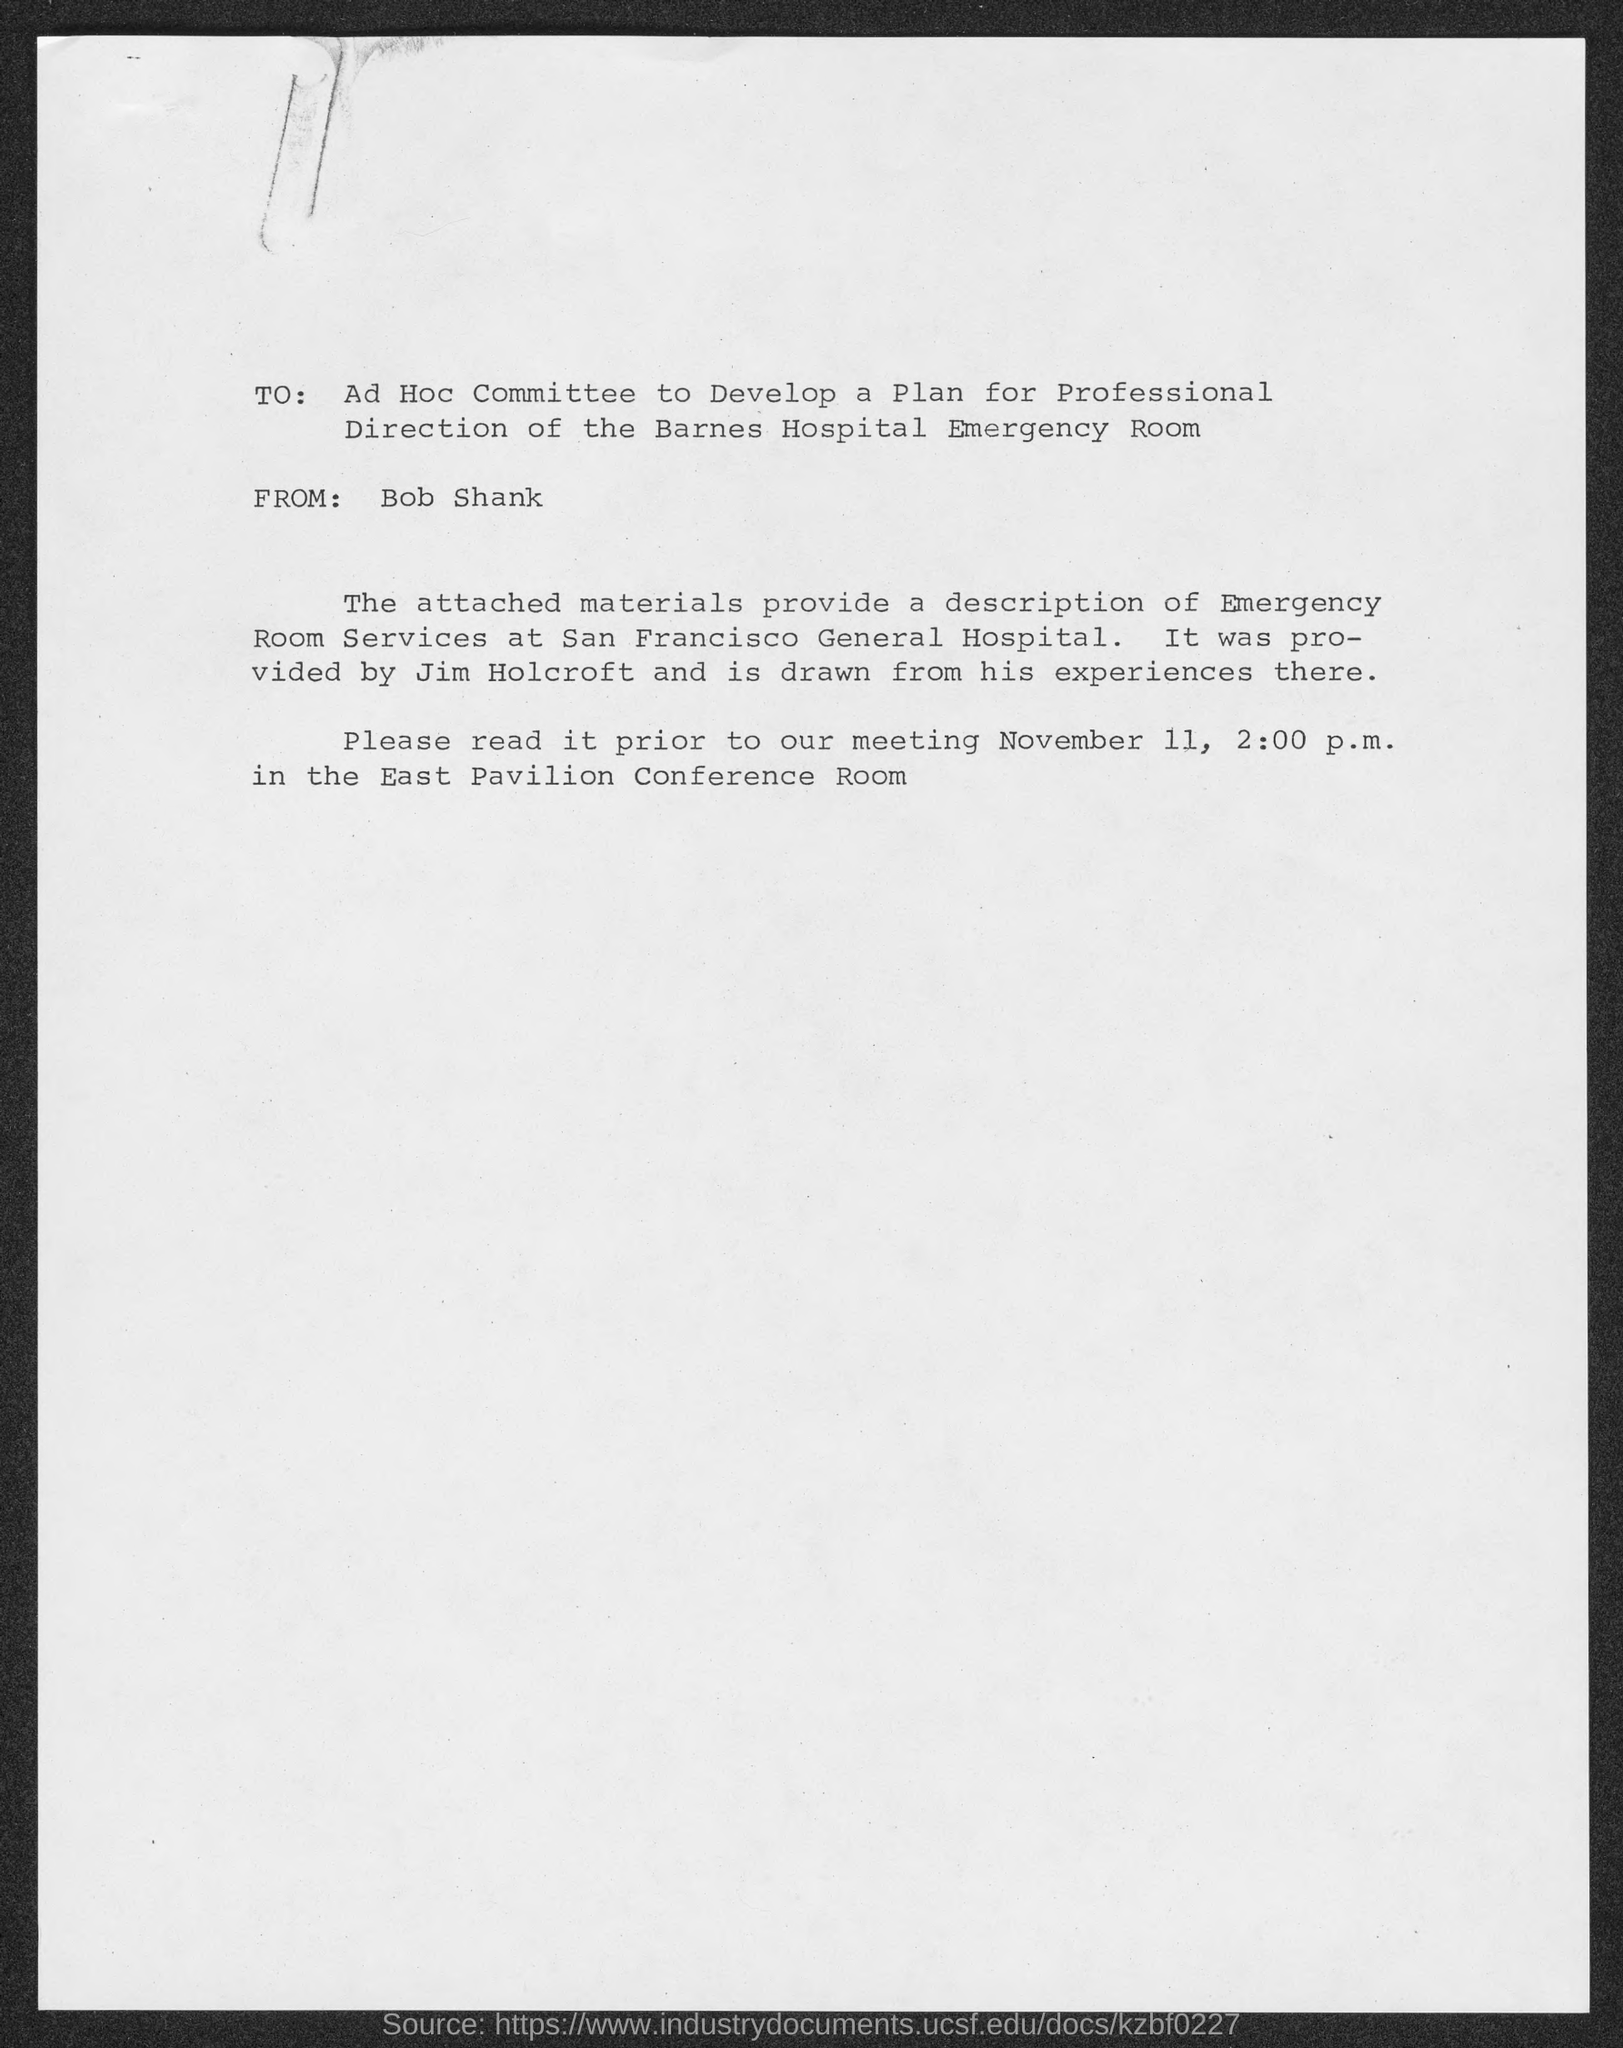Point out several critical features in this image. The meeting will be held in the East Pavilion Conference Room. The description of emergency room services at San Francisco General Hospital is provided by Jim Holcroft. The meeting is scheduled to take place at 2:00 P.M. The sender of this message is Bob Shank. The "Description of Emergency Room Services" at San Francisco General Hospital is mentioned. 